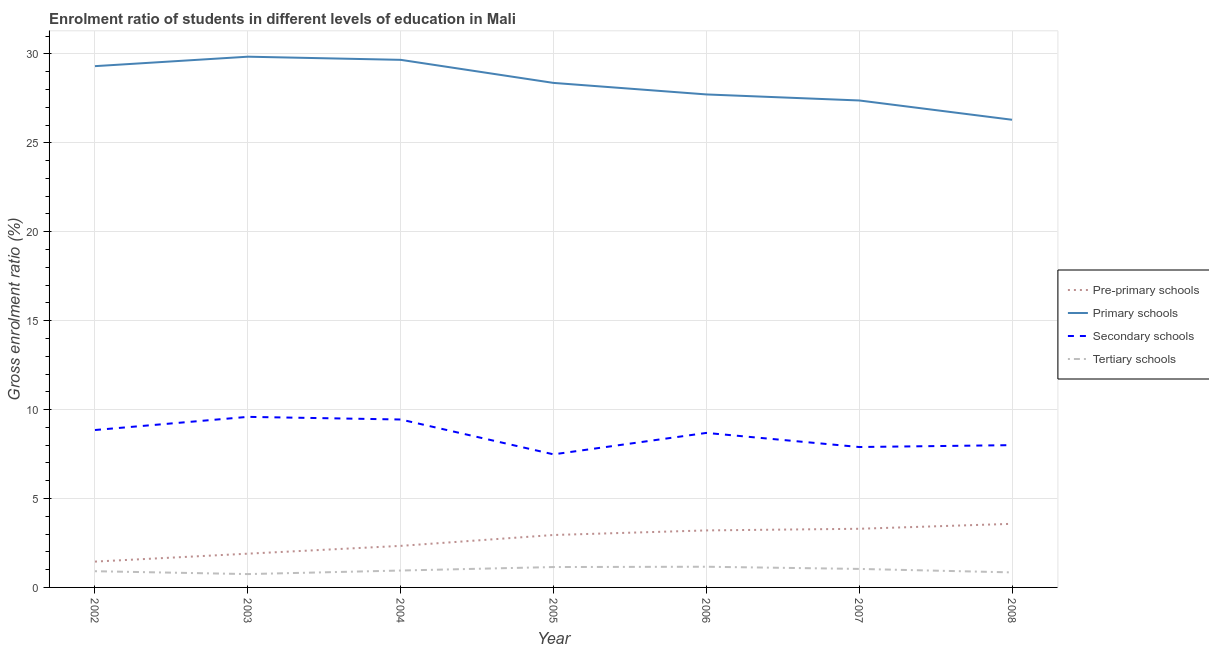How many different coloured lines are there?
Your answer should be compact. 4. What is the gross enrolment ratio in tertiary schools in 2005?
Your response must be concise. 1.15. Across all years, what is the maximum gross enrolment ratio in primary schools?
Keep it short and to the point. 29.84. Across all years, what is the minimum gross enrolment ratio in pre-primary schools?
Your answer should be compact. 1.45. In which year was the gross enrolment ratio in secondary schools maximum?
Provide a succinct answer. 2003. In which year was the gross enrolment ratio in primary schools minimum?
Ensure brevity in your answer.  2008. What is the total gross enrolment ratio in tertiary schools in the graph?
Ensure brevity in your answer.  6.81. What is the difference between the gross enrolment ratio in primary schools in 2005 and that in 2008?
Keep it short and to the point. 2.07. What is the difference between the gross enrolment ratio in primary schools in 2004 and the gross enrolment ratio in secondary schools in 2007?
Ensure brevity in your answer.  21.77. What is the average gross enrolment ratio in primary schools per year?
Make the answer very short. 28.37. In the year 2005, what is the difference between the gross enrolment ratio in primary schools and gross enrolment ratio in tertiary schools?
Give a very brief answer. 27.22. In how many years, is the gross enrolment ratio in secondary schools greater than 3 %?
Offer a terse response. 7. What is the ratio of the gross enrolment ratio in secondary schools in 2006 to that in 2007?
Your answer should be very brief. 1.1. Is the gross enrolment ratio in tertiary schools in 2002 less than that in 2005?
Ensure brevity in your answer.  Yes. What is the difference between the highest and the second highest gross enrolment ratio in tertiary schools?
Your answer should be very brief. 0.02. What is the difference between the highest and the lowest gross enrolment ratio in primary schools?
Give a very brief answer. 3.55. Does the gross enrolment ratio in secondary schools monotonically increase over the years?
Keep it short and to the point. No. Is the gross enrolment ratio in pre-primary schools strictly less than the gross enrolment ratio in tertiary schools over the years?
Provide a short and direct response. No. How many lines are there?
Keep it short and to the point. 4. Are the values on the major ticks of Y-axis written in scientific E-notation?
Provide a short and direct response. No. Does the graph contain any zero values?
Ensure brevity in your answer.  No. Does the graph contain grids?
Offer a terse response. Yes. How are the legend labels stacked?
Offer a terse response. Vertical. What is the title of the graph?
Make the answer very short. Enrolment ratio of students in different levels of education in Mali. What is the label or title of the X-axis?
Offer a terse response. Year. What is the Gross enrolment ratio (%) in Pre-primary schools in 2002?
Your answer should be compact. 1.45. What is the Gross enrolment ratio (%) in Primary schools in 2002?
Make the answer very short. 29.31. What is the Gross enrolment ratio (%) in Secondary schools in 2002?
Ensure brevity in your answer.  8.85. What is the Gross enrolment ratio (%) of Tertiary schools in 2002?
Your answer should be compact. 0.91. What is the Gross enrolment ratio (%) in Pre-primary schools in 2003?
Make the answer very short. 1.9. What is the Gross enrolment ratio (%) of Primary schools in 2003?
Your answer should be compact. 29.84. What is the Gross enrolment ratio (%) of Secondary schools in 2003?
Give a very brief answer. 9.59. What is the Gross enrolment ratio (%) of Tertiary schools in 2003?
Give a very brief answer. 0.75. What is the Gross enrolment ratio (%) in Pre-primary schools in 2004?
Your response must be concise. 2.34. What is the Gross enrolment ratio (%) of Primary schools in 2004?
Your response must be concise. 29.67. What is the Gross enrolment ratio (%) in Secondary schools in 2004?
Ensure brevity in your answer.  9.44. What is the Gross enrolment ratio (%) of Tertiary schools in 2004?
Make the answer very short. 0.95. What is the Gross enrolment ratio (%) in Pre-primary schools in 2005?
Your response must be concise. 2.95. What is the Gross enrolment ratio (%) in Primary schools in 2005?
Make the answer very short. 28.37. What is the Gross enrolment ratio (%) of Secondary schools in 2005?
Provide a short and direct response. 7.48. What is the Gross enrolment ratio (%) of Tertiary schools in 2005?
Your response must be concise. 1.15. What is the Gross enrolment ratio (%) of Pre-primary schools in 2006?
Make the answer very short. 3.21. What is the Gross enrolment ratio (%) of Primary schools in 2006?
Provide a succinct answer. 27.72. What is the Gross enrolment ratio (%) in Secondary schools in 2006?
Your answer should be compact. 8.69. What is the Gross enrolment ratio (%) of Tertiary schools in 2006?
Provide a short and direct response. 1.16. What is the Gross enrolment ratio (%) of Pre-primary schools in 2007?
Offer a very short reply. 3.3. What is the Gross enrolment ratio (%) in Primary schools in 2007?
Your answer should be very brief. 27.38. What is the Gross enrolment ratio (%) in Secondary schools in 2007?
Keep it short and to the point. 7.9. What is the Gross enrolment ratio (%) of Tertiary schools in 2007?
Offer a terse response. 1.04. What is the Gross enrolment ratio (%) of Pre-primary schools in 2008?
Give a very brief answer. 3.58. What is the Gross enrolment ratio (%) of Primary schools in 2008?
Offer a very short reply. 26.3. What is the Gross enrolment ratio (%) of Secondary schools in 2008?
Provide a short and direct response. 8. What is the Gross enrolment ratio (%) in Tertiary schools in 2008?
Keep it short and to the point. 0.85. Across all years, what is the maximum Gross enrolment ratio (%) of Pre-primary schools?
Your response must be concise. 3.58. Across all years, what is the maximum Gross enrolment ratio (%) of Primary schools?
Offer a very short reply. 29.84. Across all years, what is the maximum Gross enrolment ratio (%) in Secondary schools?
Your answer should be compact. 9.59. Across all years, what is the maximum Gross enrolment ratio (%) of Tertiary schools?
Your response must be concise. 1.16. Across all years, what is the minimum Gross enrolment ratio (%) in Pre-primary schools?
Your answer should be very brief. 1.45. Across all years, what is the minimum Gross enrolment ratio (%) of Primary schools?
Offer a very short reply. 26.3. Across all years, what is the minimum Gross enrolment ratio (%) in Secondary schools?
Provide a succinct answer. 7.48. Across all years, what is the minimum Gross enrolment ratio (%) of Tertiary schools?
Your answer should be very brief. 0.75. What is the total Gross enrolment ratio (%) of Pre-primary schools in the graph?
Provide a succinct answer. 18.72. What is the total Gross enrolment ratio (%) of Primary schools in the graph?
Your answer should be compact. 198.6. What is the total Gross enrolment ratio (%) in Secondary schools in the graph?
Offer a terse response. 59.95. What is the total Gross enrolment ratio (%) of Tertiary schools in the graph?
Ensure brevity in your answer.  6.81. What is the difference between the Gross enrolment ratio (%) in Pre-primary schools in 2002 and that in 2003?
Give a very brief answer. -0.45. What is the difference between the Gross enrolment ratio (%) in Primary schools in 2002 and that in 2003?
Ensure brevity in your answer.  -0.53. What is the difference between the Gross enrolment ratio (%) in Secondary schools in 2002 and that in 2003?
Give a very brief answer. -0.74. What is the difference between the Gross enrolment ratio (%) of Tertiary schools in 2002 and that in 2003?
Your answer should be very brief. 0.16. What is the difference between the Gross enrolment ratio (%) in Pre-primary schools in 2002 and that in 2004?
Your answer should be very brief. -0.88. What is the difference between the Gross enrolment ratio (%) of Primary schools in 2002 and that in 2004?
Your response must be concise. -0.35. What is the difference between the Gross enrolment ratio (%) of Secondary schools in 2002 and that in 2004?
Keep it short and to the point. -0.59. What is the difference between the Gross enrolment ratio (%) in Tertiary schools in 2002 and that in 2004?
Provide a short and direct response. -0.04. What is the difference between the Gross enrolment ratio (%) in Pre-primary schools in 2002 and that in 2005?
Offer a terse response. -1.5. What is the difference between the Gross enrolment ratio (%) in Primary schools in 2002 and that in 2005?
Your response must be concise. 0.94. What is the difference between the Gross enrolment ratio (%) in Secondary schools in 2002 and that in 2005?
Make the answer very short. 1.37. What is the difference between the Gross enrolment ratio (%) of Tertiary schools in 2002 and that in 2005?
Offer a very short reply. -0.23. What is the difference between the Gross enrolment ratio (%) in Pre-primary schools in 2002 and that in 2006?
Keep it short and to the point. -1.75. What is the difference between the Gross enrolment ratio (%) of Primary schools in 2002 and that in 2006?
Give a very brief answer. 1.59. What is the difference between the Gross enrolment ratio (%) of Secondary schools in 2002 and that in 2006?
Make the answer very short. 0.16. What is the difference between the Gross enrolment ratio (%) of Tertiary schools in 2002 and that in 2006?
Make the answer very short. -0.25. What is the difference between the Gross enrolment ratio (%) of Pre-primary schools in 2002 and that in 2007?
Provide a short and direct response. -1.85. What is the difference between the Gross enrolment ratio (%) in Primary schools in 2002 and that in 2007?
Ensure brevity in your answer.  1.93. What is the difference between the Gross enrolment ratio (%) in Secondary schools in 2002 and that in 2007?
Provide a short and direct response. 0.96. What is the difference between the Gross enrolment ratio (%) in Tertiary schools in 2002 and that in 2007?
Provide a succinct answer. -0.13. What is the difference between the Gross enrolment ratio (%) of Pre-primary schools in 2002 and that in 2008?
Keep it short and to the point. -2.12. What is the difference between the Gross enrolment ratio (%) of Primary schools in 2002 and that in 2008?
Provide a short and direct response. 3.01. What is the difference between the Gross enrolment ratio (%) of Secondary schools in 2002 and that in 2008?
Your response must be concise. 0.85. What is the difference between the Gross enrolment ratio (%) in Tertiary schools in 2002 and that in 2008?
Your answer should be very brief. 0.07. What is the difference between the Gross enrolment ratio (%) of Pre-primary schools in 2003 and that in 2004?
Offer a terse response. -0.44. What is the difference between the Gross enrolment ratio (%) of Primary schools in 2003 and that in 2004?
Offer a very short reply. 0.18. What is the difference between the Gross enrolment ratio (%) of Secondary schools in 2003 and that in 2004?
Your answer should be very brief. 0.15. What is the difference between the Gross enrolment ratio (%) in Tertiary schools in 2003 and that in 2004?
Ensure brevity in your answer.  -0.2. What is the difference between the Gross enrolment ratio (%) in Pre-primary schools in 2003 and that in 2005?
Your response must be concise. -1.05. What is the difference between the Gross enrolment ratio (%) of Primary schools in 2003 and that in 2005?
Offer a terse response. 1.47. What is the difference between the Gross enrolment ratio (%) in Secondary schools in 2003 and that in 2005?
Give a very brief answer. 2.11. What is the difference between the Gross enrolment ratio (%) of Tertiary schools in 2003 and that in 2005?
Provide a succinct answer. -0.4. What is the difference between the Gross enrolment ratio (%) of Pre-primary schools in 2003 and that in 2006?
Provide a short and direct response. -1.31. What is the difference between the Gross enrolment ratio (%) in Primary schools in 2003 and that in 2006?
Provide a succinct answer. 2.12. What is the difference between the Gross enrolment ratio (%) in Secondary schools in 2003 and that in 2006?
Keep it short and to the point. 0.9. What is the difference between the Gross enrolment ratio (%) of Tertiary schools in 2003 and that in 2006?
Provide a short and direct response. -0.41. What is the difference between the Gross enrolment ratio (%) in Pre-primary schools in 2003 and that in 2007?
Offer a terse response. -1.4. What is the difference between the Gross enrolment ratio (%) in Primary schools in 2003 and that in 2007?
Your answer should be very brief. 2.46. What is the difference between the Gross enrolment ratio (%) in Secondary schools in 2003 and that in 2007?
Your answer should be very brief. 1.7. What is the difference between the Gross enrolment ratio (%) in Tertiary schools in 2003 and that in 2007?
Give a very brief answer. -0.29. What is the difference between the Gross enrolment ratio (%) in Pre-primary schools in 2003 and that in 2008?
Your answer should be compact. -1.68. What is the difference between the Gross enrolment ratio (%) of Primary schools in 2003 and that in 2008?
Give a very brief answer. 3.55. What is the difference between the Gross enrolment ratio (%) in Secondary schools in 2003 and that in 2008?
Your response must be concise. 1.59. What is the difference between the Gross enrolment ratio (%) of Tertiary schools in 2003 and that in 2008?
Keep it short and to the point. -0.1. What is the difference between the Gross enrolment ratio (%) of Pre-primary schools in 2004 and that in 2005?
Keep it short and to the point. -0.61. What is the difference between the Gross enrolment ratio (%) in Primary schools in 2004 and that in 2005?
Keep it short and to the point. 1.3. What is the difference between the Gross enrolment ratio (%) in Secondary schools in 2004 and that in 2005?
Give a very brief answer. 1.96. What is the difference between the Gross enrolment ratio (%) in Tertiary schools in 2004 and that in 2005?
Ensure brevity in your answer.  -0.2. What is the difference between the Gross enrolment ratio (%) of Pre-primary schools in 2004 and that in 2006?
Provide a short and direct response. -0.87. What is the difference between the Gross enrolment ratio (%) in Primary schools in 2004 and that in 2006?
Provide a short and direct response. 1.95. What is the difference between the Gross enrolment ratio (%) of Secondary schools in 2004 and that in 2006?
Give a very brief answer. 0.75. What is the difference between the Gross enrolment ratio (%) of Tertiary schools in 2004 and that in 2006?
Offer a terse response. -0.21. What is the difference between the Gross enrolment ratio (%) of Pre-primary schools in 2004 and that in 2007?
Provide a succinct answer. -0.96. What is the difference between the Gross enrolment ratio (%) in Primary schools in 2004 and that in 2007?
Your response must be concise. 2.28. What is the difference between the Gross enrolment ratio (%) in Secondary schools in 2004 and that in 2007?
Give a very brief answer. 1.55. What is the difference between the Gross enrolment ratio (%) in Tertiary schools in 2004 and that in 2007?
Offer a terse response. -0.09. What is the difference between the Gross enrolment ratio (%) of Pre-primary schools in 2004 and that in 2008?
Offer a very short reply. -1.24. What is the difference between the Gross enrolment ratio (%) of Primary schools in 2004 and that in 2008?
Ensure brevity in your answer.  3.37. What is the difference between the Gross enrolment ratio (%) in Secondary schools in 2004 and that in 2008?
Offer a very short reply. 1.44. What is the difference between the Gross enrolment ratio (%) of Tertiary schools in 2004 and that in 2008?
Offer a terse response. 0.1. What is the difference between the Gross enrolment ratio (%) of Pre-primary schools in 2005 and that in 2006?
Ensure brevity in your answer.  -0.26. What is the difference between the Gross enrolment ratio (%) of Primary schools in 2005 and that in 2006?
Your answer should be very brief. 0.65. What is the difference between the Gross enrolment ratio (%) in Secondary schools in 2005 and that in 2006?
Ensure brevity in your answer.  -1.21. What is the difference between the Gross enrolment ratio (%) in Tertiary schools in 2005 and that in 2006?
Your answer should be compact. -0.02. What is the difference between the Gross enrolment ratio (%) of Pre-primary schools in 2005 and that in 2007?
Offer a terse response. -0.35. What is the difference between the Gross enrolment ratio (%) in Primary schools in 2005 and that in 2007?
Your response must be concise. 0.99. What is the difference between the Gross enrolment ratio (%) of Secondary schools in 2005 and that in 2007?
Offer a terse response. -0.41. What is the difference between the Gross enrolment ratio (%) in Tertiary schools in 2005 and that in 2007?
Give a very brief answer. 0.11. What is the difference between the Gross enrolment ratio (%) of Pre-primary schools in 2005 and that in 2008?
Your answer should be compact. -0.63. What is the difference between the Gross enrolment ratio (%) in Primary schools in 2005 and that in 2008?
Ensure brevity in your answer.  2.07. What is the difference between the Gross enrolment ratio (%) in Secondary schools in 2005 and that in 2008?
Keep it short and to the point. -0.52. What is the difference between the Gross enrolment ratio (%) of Tertiary schools in 2005 and that in 2008?
Ensure brevity in your answer.  0.3. What is the difference between the Gross enrolment ratio (%) in Pre-primary schools in 2006 and that in 2007?
Offer a very short reply. -0.09. What is the difference between the Gross enrolment ratio (%) in Primary schools in 2006 and that in 2007?
Give a very brief answer. 0.34. What is the difference between the Gross enrolment ratio (%) of Secondary schools in 2006 and that in 2007?
Provide a short and direct response. 0.79. What is the difference between the Gross enrolment ratio (%) of Tertiary schools in 2006 and that in 2007?
Ensure brevity in your answer.  0.12. What is the difference between the Gross enrolment ratio (%) in Pre-primary schools in 2006 and that in 2008?
Offer a terse response. -0.37. What is the difference between the Gross enrolment ratio (%) in Primary schools in 2006 and that in 2008?
Your answer should be very brief. 1.42. What is the difference between the Gross enrolment ratio (%) of Secondary schools in 2006 and that in 2008?
Give a very brief answer. 0.69. What is the difference between the Gross enrolment ratio (%) of Tertiary schools in 2006 and that in 2008?
Offer a terse response. 0.32. What is the difference between the Gross enrolment ratio (%) in Pre-primary schools in 2007 and that in 2008?
Your answer should be very brief. -0.28. What is the difference between the Gross enrolment ratio (%) in Primary schools in 2007 and that in 2008?
Your response must be concise. 1.08. What is the difference between the Gross enrolment ratio (%) of Secondary schools in 2007 and that in 2008?
Your response must be concise. -0.11. What is the difference between the Gross enrolment ratio (%) of Tertiary schools in 2007 and that in 2008?
Your answer should be compact. 0.2. What is the difference between the Gross enrolment ratio (%) in Pre-primary schools in 2002 and the Gross enrolment ratio (%) in Primary schools in 2003?
Make the answer very short. -28.39. What is the difference between the Gross enrolment ratio (%) in Pre-primary schools in 2002 and the Gross enrolment ratio (%) in Secondary schools in 2003?
Keep it short and to the point. -8.14. What is the difference between the Gross enrolment ratio (%) of Pre-primary schools in 2002 and the Gross enrolment ratio (%) of Tertiary schools in 2003?
Your answer should be very brief. 0.7. What is the difference between the Gross enrolment ratio (%) in Primary schools in 2002 and the Gross enrolment ratio (%) in Secondary schools in 2003?
Your answer should be compact. 19.72. What is the difference between the Gross enrolment ratio (%) in Primary schools in 2002 and the Gross enrolment ratio (%) in Tertiary schools in 2003?
Your answer should be very brief. 28.56. What is the difference between the Gross enrolment ratio (%) in Secondary schools in 2002 and the Gross enrolment ratio (%) in Tertiary schools in 2003?
Ensure brevity in your answer.  8.1. What is the difference between the Gross enrolment ratio (%) of Pre-primary schools in 2002 and the Gross enrolment ratio (%) of Primary schools in 2004?
Make the answer very short. -28.21. What is the difference between the Gross enrolment ratio (%) in Pre-primary schools in 2002 and the Gross enrolment ratio (%) in Secondary schools in 2004?
Offer a terse response. -7.99. What is the difference between the Gross enrolment ratio (%) in Pre-primary schools in 2002 and the Gross enrolment ratio (%) in Tertiary schools in 2004?
Your answer should be compact. 0.5. What is the difference between the Gross enrolment ratio (%) in Primary schools in 2002 and the Gross enrolment ratio (%) in Secondary schools in 2004?
Keep it short and to the point. 19.87. What is the difference between the Gross enrolment ratio (%) in Primary schools in 2002 and the Gross enrolment ratio (%) in Tertiary schools in 2004?
Provide a short and direct response. 28.36. What is the difference between the Gross enrolment ratio (%) of Secondary schools in 2002 and the Gross enrolment ratio (%) of Tertiary schools in 2004?
Offer a terse response. 7.9. What is the difference between the Gross enrolment ratio (%) of Pre-primary schools in 2002 and the Gross enrolment ratio (%) of Primary schools in 2005?
Make the answer very short. -26.92. What is the difference between the Gross enrolment ratio (%) of Pre-primary schools in 2002 and the Gross enrolment ratio (%) of Secondary schools in 2005?
Keep it short and to the point. -6.03. What is the difference between the Gross enrolment ratio (%) of Pre-primary schools in 2002 and the Gross enrolment ratio (%) of Tertiary schools in 2005?
Offer a terse response. 0.31. What is the difference between the Gross enrolment ratio (%) of Primary schools in 2002 and the Gross enrolment ratio (%) of Secondary schools in 2005?
Keep it short and to the point. 21.83. What is the difference between the Gross enrolment ratio (%) of Primary schools in 2002 and the Gross enrolment ratio (%) of Tertiary schools in 2005?
Provide a short and direct response. 28.17. What is the difference between the Gross enrolment ratio (%) in Secondary schools in 2002 and the Gross enrolment ratio (%) in Tertiary schools in 2005?
Ensure brevity in your answer.  7.71. What is the difference between the Gross enrolment ratio (%) of Pre-primary schools in 2002 and the Gross enrolment ratio (%) of Primary schools in 2006?
Ensure brevity in your answer.  -26.27. What is the difference between the Gross enrolment ratio (%) of Pre-primary schools in 2002 and the Gross enrolment ratio (%) of Secondary schools in 2006?
Give a very brief answer. -7.24. What is the difference between the Gross enrolment ratio (%) of Pre-primary schools in 2002 and the Gross enrolment ratio (%) of Tertiary schools in 2006?
Offer a very short reply. 0.29. What is the difference between the Gross enrolment ratio (%) of Primary schools in 2002 and the Gross enrolment ratio (%) of Secondary schools in 2006?
Provide a short and direct response. 20.62. What is the difference between the Gross enrolment ratio (%) in Primary schools in 2002 and the Gross enrolment ratio (%) in Tertiary schools in 2006?
Provide a short and direct response. 28.15. What is the difference between the Gross enrolment ratio (%) in Secondary schools in 2002 and the Gross enrolment ratio (%) in Tertiary schools in 2006?
Make the answer very short. 7.69. What is the difference between the Gross enrolment ratio (%) in Pre-primary schools in 2002 and the Gross enrolment ratio (%) in Primary schools in 2007?
Your response must be concise. -25.93. What is the difference between the Gross enrolment ratio (%) in Pre-primary schools in 2002 and the Gross enrolment ratio (%) in Secondary schools in 2007?
Ensure brevity in your answer.  -6.44. What is the difference between the Gross enrolment ratio (%) of Pre-primary schools in 2002 and the Gross enrolment ratio (%) of Tertiary schools in 2007?
Keep it short and to the point. 0.41. What is the difference between the Gross enrolment ratio (%) of Primary schools in 2002 and the Gross enrolment ratio (%) of Secondary schools in 2007?
Make the answer very short. 21.42. What is the difference between the Gross enrolment ratio (%) of Primary schools in 2002 and the Gross enrolment ratio (%) of Tertiary schools in 2007?
Your response must be concise. 28.27. What is the difference between the Gross enrolment ratio (%) in Secondary schools in 2002 and the Gross enrolment ratio (%) in Tertiary schools in 2007?
Make the answer very short. 7.81. What is the difference between the Gross enrolment ratio (%) in Pre-primary schools in 2002 and the Gross enrolment ratio (%) in Primary schools in 2008?
Give a very brief answer. -24.85. What is the difference between the Gross enrolment ratio (%) in Pre-primary schools in 2002 and the Gross enrolment ratio (%) in Secondary schools in 2008?
Ensure brevity in your answer.  -6.55. What is the difference between the Gross enrolment ratio (%) in Pre-primary schools in 2002 and the Gross enrolment ratio (%) in Tertiary schools in 2008?
Provide a short and direct response. 0.61. What is the difference between the Gross enrolment ratio (%) in Primary schools in 2002 and the Gross enrolment ratio (%) in Secondary schools in 2008?
Your answer should be very brief. 21.31. What is the difference between the Gross enrolment ratio (%) of Primary schools in 2002 and the Gross enrolment ratio (%) of Tertiary schools in 2008?
Offer a terse response. 28.47. What is the difference between the Gross enrolment ratio (%) in Secondary schools in 2002 and the Gross enrolment ratio (%) in Tertiary schools in 2008?
Keep it short and to the point. 8.01. What is the difference between the Gross enrolment ratio (%) of Pre-primary schools in 2003 and the Gross enrolment ratio (%) of Primary schools in 2004?
Offer a very short reply. -27.77. What is the difference between the Gross enrolment ratio (%) of Pre-primary schools in 2003 and the Gross enrolment ratio (%) of Secondary schools in 2004?
Provide a succinct answer. -7.54. What is the difference between the Gross enrolment ratio (%) of Pre-primary schools in 2003 and the Gross enrolment ratio (%) of Tertiary schools in 2004?
Offer a very short reply. 0.95. What is the difference between the Gross enrolment ratio (%) in Primary schools in 2003 and the Gross enrolment ratio (%) in Secondary schools in 2004?
Give a very brief answer. 20.4. What is the difference between the Gross enrolment ratio (%) in Primary schools in 2003 and the Gross enrolment ratio (%) in Tertiary schools in 2004?
Ensure brevity in your answer.  28.89. What is the difference between the Gross enrolment ratio (%) in Secondary schools in 2003 and the Gross enrolment ratio (%) in Tertiary schools in 2004?
Keep it short and to the point. 8.64. What is the difference between the Gross enrolment ratio (%) in Pre-primary schools in 2003 and the Gross enrolment ratio (%) in Primary schools in 2005?
Offer a terse response. -26.47. What is the difference between the Gross enrolment ratio (%) in Pre-primary schools in 2003 and the Gross enrolment ratio (%) in Secondary schools in 2005?
Your response must be concise. -5.58. What is the difference between the Gross enrolment ratio (%) in Pre-primary schools in 2003 and the Gross enrolment ratio (%) in Tertiary schools in 2005?
Give a very brief answer. 0.75. What is the difference between the Gross enrolment ratio (%) of Primary schools in 2003 and the Gross enrolment ratio (%) of Secondary schools in 2005?
Provide a succinct answer. 22.36. What is the difference between the Gross enrolment ratio (%) in Primary schools in 2003 and the Gross enrolment ratio (%) in Tertiary schools in 2005?
Offer a very short reply. 28.7. What is the difference between the Gross enrolment ratio (%) in Secondary schools in 2003 and the Gross enrolment ratio (%) in Tertiary schools in 2005?
Give a very brief answer. 8.44. What is the difference between the Gross enrolment ratio (%) in Pre-primary schools in 2003 and the Gross enrolment ratio (%) in Primary schools in 2006?
Provide a succinct answer. -25.82. What is the difference between the Gross enrolment ratio (%) of Pre-primary schools in 2003 and the Gross enrolment ratio (%) of Secondary schools in 2006?
Provide a short and direct response. -6.79. What is the difference between the Gross enrolment ratio (%) of Pre-primary schools in 2003 and the Gross enrolment ratio (%) of Tertiary schools in 2006?
Your answer should be compact. 0.73. What is the difference between the Gross enrolment ratio (%) in Primary schools in 2003 and the Gross enrolment ratio (%) in Secondary schools in 2006?
Your answer should be very brief. 21.16. What is the difference between the Gross enrolment ratio (%) of Primary schools in 2003 and the Gross enrolment ratio (%) of Tertiary schools in 2006?
Keep it short and to the point. 28.68. What is the difference between the Gross enrolment ratio (%) of Secondary schools in 2003 and the Gross enrolment ratio (%) of Tertiary schools in 2006?
Your answer should be very brief. 8.43. What is the difference between the Gross enrolment ratio (%) of Pre-primary schools in 2003 and the Gross enrolment ratio (%) of Primary schools in 2007?
Keep it short and to the point. -25.48. What is the difference between the Gross enrolment ratio (%) of Pre-primary schools in 2003 and the Gross enrolment ratio (%) of Secondary schools in 2007?
Your answer should be very brief. -6. What is the difference between the Gross enrolment ratio (%) in Pre-primary schools in 2003 and the Gross enrolment ratio (%) in Tertiary schools in 2007?
Offer a terse response. 0.86. What is the difference between the Gross enrolment ratio (%) of Primary schools in 2003 and the Gross enrolment ratio (%) of Secondary schools in 2007?
Offer a terse response. 21.95. What is the difference between the Gross enrolment ratio (%) in Primary schools in 2003 and the Gross enrolment ratio (%) in Tertiary schools in 2007?
Provide a succinct answer. 28.8. What is the difference between the Gross enrolment ratio (%) of Secondary schools in 2003 and the Gross enrolment ratio (%) of Tertiary schools in 2007?
Provide a short and direct response. 8.55. What is the difference between the Gross enrolment ratio (%) in Pre-primary schools in 2003 and the Gross enrolment ratio (%) in Primary schools in 2008?
Your response must be concise. -24.4. What is the difference between the Gross enrolment ratio (%) of Pre-primary schools in 2003 and the Gross enrolment ratio (%) of Secondary schools in 2008?
Give a very brief answer. -6.1. What is the difference between the Gross enrolment ratio (%) in Pre-primary schools in 2003 and the Gross enrolment ratio (%) in Tertiary schools in 2008?
Offer a very short reply. 1.05. What is the difference between the Gross enrolment ratio (%) of Primary schools in 2003 and the Gross enrolment ratio (%) of Secondary schools in 2008?
Keep it short and to the point. 21.84. What is the difference between the Gross enrolment ratio (%) in Primary schools in 2003 and the Gross enrolment ratio (%) in Tertiary schools in 2008?
Keep it short and to the point. 29. What is the difference between the Gross enrolment ratio (%) of Secondary schools in 2003 and the Gross enrolment ratio (%) of Tertiary schools in 2008?
Provide a short and direct response. 8.75. What is the difference between the Gross enrolment ratio (%) of Pre-primary schools in 2004 and the Gross enrolment ratio (%) of Primary schools in 2005?
Keep it short and to the point. -26.03. What is the difference between the Gross enrolment ratio (%) of Pre-primary schools in 2004 and the Gross enrolment ratio (%) of Secondary schools in 2005?
Give a very brief answer. -5.15. What is the difference between the Gross enrolment ratio (%) in Pre-primary schools in 2004 and the Gross enrolment ratio (%) in Tertiary schools in 2005?
Offer a very short reply. 1.19. What is the difference between the Gross enrolment ratio (%) of Primary schools in 2004 and the Gross enrolment ratio (%) of Secondary schools in 2005?
Your answer should be compact. 22.18. What is the difference between the Gross enrolment ratio (%) of Primary schools in 2004 and the Gross enrolment ratio (%) of Tertiary schools in 2005?
Your response must be concise. 28.52. What is the difference between the Gross enrolment ratio (%) of Secondary schools in 2004 and the Gross enrolment ratio (%) of Tertiary schools in 2005?
Keep it short and to the point. 8.3. What is the difference between the Gross enrolment ratio (%) of Pre-primary schools in 2004 and the Gross enrolment ratio (%) of Primary schools in 2006?
Your response must be concise. -25.39. What is the difference between the Gross enrolment ratio (%) in Pre-primary schools in 2004 and the Gross enrolment ratio (%) in Secondary schools in 2006?
Ensure brevity in your answer.  -6.35. What is the difference between the Gross enrolment ratio (%) in Pre-primary schools in 2004 and the Gross enrolment ratio (%) in Tertiary schools in 2006?
Ensure brevity in your answer.  1.17. What is the difference between the Gross enrolment ratio (%) in Primary schools in 2004 and the Gross enrolment ratio (%) in Secondary schools in 2006?
Your answer should be compact. 20.98. What is the difference between the Gross enrolment ratio (%) of Primary schools in 2004 and the Gross enrolment ratio (%) of Tertiary schools in 2006?
Give a very brief answer. 28.5. What is the difference between the Gross enrolment ratio (%) of Secondary schools in 2004 and the Gross enrolment ratio (%) of Tertiary schools in 2006?
Give a very brief answer. 8.28. What is the difference between the Gross enrolment ratio (%) in Pre-primary schools in 2004 and the Gross enrolment ratio (%) in Primary schools in 2007?
Keep it short and to the point. -25.05. What is the difference between the Gross enrolment ratio (%) of Pre-primary schools in 2004 and the Gross enrolment ratio (%) of Secondary schools in 2007?
Ensure brevity in your answer.  -5.56. What is the difference between the Gross enrolment ratio (%) in Pre-primary schools in 2004 and the Gross enrolment ratio (%) in Tertiary schools in 2007?
Your response must be concise. 1.3. What is the difference between the Gross enrolment ratio (%) of Primary schools in 2004 and the Gross enrolment ratio (%) of Secondary schools in 2007?
Provide a succinct answer. 21.77. What is the difference between the Gross enrolment ratio (%) of Primary schools in 2004 and the Gross enrolment ratio (%) of Tertiary schools in 2007?
Make the answer very short. 28.63. What is the difference between the Gross enrolment ratio (%) in Secondary schools in 2004 and the Gross enrolment ratio (%) in Tertiary schools in 2007?
Keep it short and to the point. 8.4. What is the difference between the Gross enrolment ratio (%) of Pre-primary schools in 2004 and the Gross enrolment ratio (%) of Primary schools in 2008?
Your answer should be very brief. -23.96. What is the difference between the Gross enrolment ratio (%) in Pre-primary schools in 2004 and the Gross enrolment ratio (%) in Secondary schools in 2008?
Provide a succinct answer. -5.66. What is the difference between the Gross enrolment ratio (%) of Pre-primary schools in 2004 and the Gross enrolment ratio (%) of Tertiary schools in 2008?
Offer a terse response. 1.49. What is the difference between the Gross enrolment ratio (%) in Primary schools in 2004 and the Gross enrolment ratio (%) in Secondary schools in 2008?
Offer a terse response. 21.67. What is the difference between the Gross enrolment ratio (%) in Primary schools in 2004 and the Gross enrolment ratio (%) in Tertiary schools in 2008?
Your response must be concise. 28.82. What is the difference between the Gross enrolment ratio (%) of Secondary schools in 2004 and the Gross enrolment ratio (%) of Tertiary schools in 2008?
Offer a terse response. 8.6. What is the difference between the Gross enrolment ratio (%) in Pre-primary schools in 2005 and the Gross enrolment ratio (%) in Primary schools in 2006?
Your answer should be very brief. -24.77. What is the difference between the Gross enrolment ratio (%) in Pre-primary schools in 2005 and the Gross enrolment ratio (%) in Secondary schools in 2006?
Your answer should be compact. -5.74. What is the difference between the Gross enrolment ratio (%) of Pre-primary schools in 2005 and the Gross enrolment ratio (%) of Tertiary schools in 2006?
Ensure brevity in your answer.  1.78. What is the difference between the Gross enrolment ratio (%) of Primary schools in 2005 and the Gross enrolment ratio (%) of Secondary schools in 2006?
Your response must be concise. 19.68. What is the difference between the Gross enrolment ratio (%) of Primary schools in 2005 and the Gross enrolment ratio (%) of Tertiary schools in 2006?
Your answer should be compact. 27.21. What is the difference between the Gross enrolment ratio (%) in Secondary schools in 2005 and the Gross enrolment ratio (%) in Tertiary schools in 2006?
Provide a succinct answer. 6.32. What is the difference between the Gross enrolment ratio (%) in Pre-primary schools in 2005 and the Gross enrolment ratio (%) in Primary schools in 2007?
Your response must be concise. -24.43. What is the difference between the Gross enrolment ratio (%) of Pre-primary schools in 2005 and the Gross enrolment ratio (%) of Secondary schools in 2007?
Ensure brevity in your answer.  -4.95. What is the difference between the Gross enrolment ratio (%) of Pre-primary schools in 2005 and the Gross enrolment ratio (%) of Tertiary schools in 2007?
Provide a succinct answer. 1.91. What is the difference between the Gross enrolment ratio (%) in Primary schools in 2005 and the Gross enrolment ratio (%) in Secondary schools in 2007?
Your answer should be very brief. 20.47. What is the difference between the Gross enrolment ratio (%) in Primary schools in 2005 and the Gross enrolment ratio (%) in Tertiary schools in 2007?
Ensure brevity in your answer.  27.33. What is the difference between the Gross enrolment ratio (%) of Secondary schools in 2005 and the Gross enrolment ratio (%) of Tertiary schools in 2007?
Give a very brief answer. 6.44. What is the difference between the Gross enrolment ratio (%) in Pre-primary schools in 2005 and the Gross enrolment ratio (%) in Primary schools in 2008?
Your answer should be very brief. -23.35. What is the difference between the Gross enrolment ratio (%) of Pre-primary schools in 2005 and the Gross enrolment ratio (%) of Secondary schools in 2008?
Provide a short and direct response. -5.05. What is the difference between the Gross enrolment ratio (%) in Pre-primary schools in 2005 and the Gross enrolment ratio (%) in Tertiary schools in 2008?
Give a very brief answer. 2.1. What is the difference between the Gross enrolment ratio (%) in Primary schools in 2005 and the Gross enrolment ratio (%) in Secondary schools in 2008?
Your answer should be compact. 20.37. What is the difference between the Gross enrolment ratio (%) of Primary schools in 2005 and the Gross enrolment ratio (%) of Tertiary schools in 2008?
Your answer should be compact. 27.52. What is the difference between the Gross enrolment ratio (%) of Secondary schools in 2005 and the Gross enrolment ratio (%) of Tertiary schools in 2008?
Provide a succinct answer. 6.64. What is the difference between the Gross enrolment ratio (%) of Pre-primary schools in 2006 and the Gross enrolment ratio (%) of Primary schools in 2007?
Your answer should be compact. -24.18. What is the difference between the Gross enrolment ratio (%) of Pre-primary schools in 2006 and the Gross enrolment ratio (%) of Secondary schools in 2007?
Give a very brief answer. -4.69. What is the difference between the Gross enrolment ratio (%) in Pre-primary schools in 2006 and the Gross enrolment ratio (%) in Tertiary schools in 2007?
Provide a succinct answer. 2.17. What is the difference between the Gross enrolment ratio (%) of Primary schools in 2006 and the Gross enrolment ratio (%) of Secondary schools in 2007?
Offer a very short reply. 19.83. What is the difference between the Gross enrolment ratio (%) in Primary schools in 2006 and the Gross enrolment ratio (%) in Tertiary schools in 2007?
Keep it short and to the point. 26.68. What is the difference between the Gross enrolment ratio (%) in Secondary schools in 2006 and the Gross enrolment ratio (%) in Tertiary schools in 2007?
Provide a succinct answer. 7.65. What is the difference between the Gross enrolment ratio (%) in Pre-primary schools in 2006 and the Gross enrolment ratio (%) in Primary schools in 2008?
Your answer should be very brief. -23.09. What is the difference between the Gross enrolment ratio (%) in Pre-primary schools in 2006 and the Gross enrolment ratio (%) in Secondary schools in 2008?
Give a very brief answer. -4.8. What is the difference between the Gross enrolment ratio (%) of Pre-primary schools in 2006 and the Gross enrolment ratio (%) of Tertiary schools in 2008?
Provide a short and direct response. 2.36. What is the difference between the Gross enrolment ratio (%) of Primary schools in 2006 and the Gross enrolment ratio (%) of Secondary schools in 2008?
Give a very brief answer. 19.72. What is the difference between the Gross enrolment ratio (%) in Primary schools in 2006 and the Gross enrolment ratio (%) in Tertiary schools in 2008?
Give a very brief answer. 26.88. What is the difference between the Gross enrolment ratio (%) in Secondary schools in 2006 and the Gross enrolment ratio (%) in Tertiary schools in 2008?
Offer a very short reply. 7.84. What is the difference between the Gross enrolment ratio (%) in Pre-primary schools in 2007 and the Gross enrolment ratio (%) in Primary schools in 2008?
Your response must be concise. -23. What is the difference between the Gross enrolment ratio (%) in Pre-primary schools in 2007 and the Gross enrolment ratio (%) in Secondary schools in 2008?
Your answer should be very brief. -4.7. What is the difference between the Gross enrolment ratio (%) of Pre-primary schools in 2007 and the Gross enrolment ratio (%) of Tertiary schools in 2008?
Provide a short and direct response. 2.45. What is the difference between the Gross enrolment ratio (%) in Primary schools in 2007 and the Gross enrolment ratio (%) in Secondary schools in 2008?
Make the answer very short. 19.38. What is the difference between the Gross enrolment ratio (%) of Primary schools in 2007 and the Gross enrolment ratio (%) of Tertiary schools in 2008?
Your response must be concise. 26.54. What is the difference between the Gross enrolment ratio (%) of Secondary schools in 2007 and the Gross enrolment ratio (%) of Tertiary schools in 2008?
Your response must be concise. 7.05. What is the average Gross enrolment ratio (%) in Pre-primary schools per year?
Ensure brevity in your answer.  2.67. What is the average Gross enrolment ratio (%) of Primary schools per year?
Keep it short and to the point. 28.37. What is the average Gross enrolment ratio (%) in Secondary schools per year?
Your answer should be very brief. 8.56. What is the average Gross enrolment ratio (%) of Tertiary schools per year?
Make the answer very short. 0.97. In the year 2002, what is the difference between the Gross enrolment ratio (%) of Pre-primary schools and Gross enrolment ratio (%) of Primary schools?
Provide a succinct answer. -27.86. In the year 2002, what is the difference between the Gross enrolment ratio (%) of Pre-primary schools and Gross enrolment ratio (%) of Secondary schools?
Offer a very short reply. -7.4. In the year 2002, what is the difference between the Gross enrolment ratio (%) of Pre-primary schools and Gross enrolment ratio (%) of Tertiary schools?
Keep it short and to the point. 0.54. In the year 2002, what is the difference between the Gross enrolment ratio (%) in Primary schools and Gross enrolment ratio (%) in Secondary schools?
Give a very brief answer. 20.46. In the year 2002, what is the difference between the Gross enrolment ratio (%) in Primary schools and Gross enrolment ratio (%) in Tertiary schools?
Provide a short and direct response. 28.4. In the year 2002, what is the difference between the Gross enrolment ratio (%) in Secondary schools and Gross enrolment ratio (%) in Tertiary schools?
Provide a short and direct response. 7.94. In the year 2003, what is the difference between the Gross enrolment ratio (%) in Pre-primary schools and Gross enrolment ratio (%) in Primary schools?
Make the answer very short. -27.95. In the year 2003, what is the difference between the Gross enrolment ratio (%) of Pre-primary schools and Gross enrolment ratio (%) of Secondary schools?
Provide a succinct answer. -7.69. In the year 2003, what is the difference between the Gross enrolment ratio (%) of Pre-primary schools and Gross enrolment ratio (%) of Tertiary schools?
Give a very brief answer. 1.15. In the year 2003, what is the difference between the Gross enrolment ratio (%) in Primary schools and Gross enrolment ratio (%) in Secondary schools?
Give a very brief answer. 20.25. In the year 2003, what is the difference between the Gross enrolment ratio (%) of Primary schools and Gross enrolment ratio (%) of Tertiary schools?
Your answer should be very brief. 29.09. In the year 2003, what is the difference between the Gross enrolment ratio (%) of Secondary schools and Gross enrolment ratio (%) of Tertiary schools?
Your answer should be very brief. 8.84. In the year 2004, what is the difference between the Gross enrolment ratio (%) in Pre-primary schools and Gross enrolment ratio (%) in Primary schools?
Offer a very short reply. -27.33. In the year 2004, what is the difference between the Gross enrolment ratio (%) of Pre-primary schools and Gross enrolment ratio (%) of Secondary schools?
Provide a short and direct response. -7.11. In the year 2004, what is the difference between the Gross enrolment ratio (%) in Pre-primary schools and Gross enrolment ratio (%) in Tertiary schools?
Your answer should be very brief. 1.39. In the year 2004, what is the difference between the Gross enrolment ratio (%) of Primary schools and Gross enrolment ratio (%) of Secondary schools?
Provide a short and direct response. 20.22. In the year 2004, what is the difference between the Gross enrolment ratio (%) of Primary schools and Gross enrolment ratio (%) of Tertiary schools?
Provide a short and direct response. 28.72. In the year 2004, what is the difference between the Gross enrolment ratio (%) in Secondary schools and Gross enrolment ratio (%) in Tertiary schools?
Provide a succinct answer. 8.49. In the year 2005, what is the difference between the Gross enrolment ratio (%) in Pre-primary schools and Gross enrolment ratio (%) in Primary schools?
Your response must be concise. -25.42. In the year 2005, what is the difference between the Gross enrolment ratio (%) in Pre-primary schools and Gross enrolment ratio (%) in Secondary schools?
Your answer should be compact. -4.53. In the year 2005, what is the difference between the Gross enrolment ratio (%) in Pre-primary schools and Gross enrolment ratio (%) in Tertiary schools?
Provide a succinct answer. 1.8. In the year 2005, what is the difference between the Gross enrolment ratio (%) in Primary schools and Gross enrolment ratio (%) in Secondary schools?
Make the answer very short. 20.89. In the year 2005, what is the difference between the Gross enrolment ratio (%) of Primary schools and Gross enrolment ratio (%) of Tertiary schools?
Provide a short and direct response. 27.22. In the year 2005, what is the difference between the Gross enrolment ratio (%) in Secondary schools and Gross enrolment ratio (%) in Tertiary schools?
Offer a very short reply. 6.34. In the year 2006, what is the difference between the Gross enrolment ratio (%) of Pre-primary schools and Gross enrolment ratio (%) of Primary schools?
Offer a terse response. -24.52. In the year 2006, what is the difference between the Gross enrolment ratio (%) of Pre-primary schools and Gross enrolment ratio (%) of Secondary schools?
Your response must be concise. -5.48. In the year 2006, what is the difference between the Gross enrolment ratio (%) of Pre-primary schools and Gross enrolment ratio (%) of Tertiary schools?
Keep it short and to the point. 2.04. In the year 2006, what is the difference between the Gross enrolment ratio (%) in Primary schools and Gross enrolment ratio (%) in Secondary schools?
Offer a terse response. 19.03. In the year 2006, what is the difference between the Gross enrolment ratio (%) in Primary schools and Gross enrolment ratio (%) in Tertiary schools?
Make the answer very short. 26.56. In the year 2006, what is the difference between the Gross enrolment ratio (%) of Secondary schools and Gross enrolment ratio (%) of Tertiary schools?
Your response must be concise. 7.53. In the year 2007, what is the difference between the Gross enrolment ratio (%) of Pre-primary schools and Gross enrolment ratio (%) of Primary schools?
Make the answer very short. -24.08. In the year 2007, what is the difference between the Gross enrolment ratio (%) in Pre-primary schools and Gross enrolment ratio (%) in Secondary schools?
Your answer should be very brief. -4.6. In the year 2007, what is the difference between the Gross enrolment ratio (%) in Pre-primary schools and Gross enrolment ratio (%) in Tertiary schools?
Your response must be concise. 2.26. In the year 2007, what is the difference between the Gross enrolment ratio (%) of Primary schools and Gross enrolment ratio (%) of Secondary schools?
Ensure brevity in your answer.  19.49. In the year 2007, what is the difference between the Gross enrolment ratio (%) in Primary schools and Gross enrolment ratio (%) in Tertiary schools?
Provide a short and direct response. 26.34. In the year 2007, what is the difference between the Gross enrolment ratio (%) of Secondary schools and Gross enrolment ratio (%) of Tertiary schools?
Your answer should be compact. 6.85. In the year 2008, what is the difference between the Gross enrolment ratio (%) in Pre-primary schools and Gross enrolment ratio (%) in Primary schools?
Ensure brevity in your answer.  -22.72. In the year 2008, what is the difference between the Gross enrolment ratio (%) in Pre-primary schools and Gross enrolment ratio (%) in Secondary schools?
Offer a very short reply. -4.42. In the year 2008, what is the difference between the Gross enrolment ratio (%) in Pre-primary schools and Gross enrolment ratio (%) in Tertiary schools?
Your response must be concise. 2.73. In the year 2008, what is the difference between the Gross enrolment ratio (%) in Primary schools and Gross enrolment ratio (%) in Secondary schools?
Offer a very short reply. 18.3. In the year 2008, what is the difference between the Gross enrolment ratio (%) of Primary schools and Gross enrolment ratio (%) of Tertiary schools?
Make the answer very short. 25.45. In the year 2008, what is the difference between the Gross enrolment ratio (%) in Secondary schools and Gross enrolment ratio (%) in Tertiary schools?
Make the answer very short. 7.16. What is the ratio of the Gross enrolment ratio (%) of Pre-primary schools in 2002 to that in 2003?
Give a very brief answer. 0.77. What is the ratio of the Gross enrolment ratio (%) in Primary schools in 2002 to that in 2003?
Make the answer very short. 0.98. What is the ratio of the Gross enrolment ratio (%) of Secondary schools in 2002 to that in 2003?
Your answer should be very brief. 0.92. What is the ratio of the Gross enrolment ratio (%) in Tertiary schools in 2002 to that in 2003?
Ensure brevity in your answer.  1.22. What is the ratio of the Gross enrolment ratio (%) in Pre-primary schools in 2002 to that in 2004?
Your answer should be compact. 0.62. What is the ratio of the Gross enrolment ratio (%) in Secondary schools in 2002 to that in 2004?
Offer a terse response. 0.94. What is the ratio of the Gross enrolment ratio (%) of Tertiary schools in 2002 to that in 2004?
Provide a succinct answer. 0.96. What is the ratio of the Gross enrolment ratio (%) of Pre-primary schools in 2002 to that in 2005?
Your answer should be very brief. 0.49. What is the ratio of the Gross enrolment ratio (%) in Primary schools in 2002 to that in 2005?
Your answer should be compact. 1.03. What is the ratio of the Gross enrolment ratio (%) in Secondary schools in 2002 to that in 2005?
Offer a very short reply. 1.18. What is the ratio of the Gross enrolment ratio (%) in Tertiary schools in 2002 to that in 2005?
Your response must be concise. 0.8. What is the ratio of the Gross enrolment ratio (%) of Pre-primary schools in 2002 to that in 2006?
Give a very brief answer. 0.45. What is the ratio of the Gross enrolment ratio (%) of Primary schools in 2002 to that in 2006?
Your response must be concise. 1.06. What is the ratio of the Gross enrolment ratio (%) of Secondary schools in 2002 to that in 2006?
Your response must be concise. 1.02. What is the ratio of the Gross enrolment ratio (%) in Tertiary schools in 2002 to that in 2006?
Give a very brief answer. 0.78. What is the ratio of the Gross enrolment ratio (%) in Pre-primary schools in 2002 to that in 2007?
Make the answer very short. 0.44. What is the ratio of the Gross enrolment ratio (%) in Primary schools in 2002 to that in 2007?
Ensure brevity in your answer.  1.07. What is the ratio of the Gross enrolment ratio (%) of Secondary schools in 2002 to that in 2007?
Make the answer very short. 1.12. What is the ratio of the Gross enrolment ratio (%) in Tertiary schools in 2002 to that in 2007?
Give a very brief answer. 0.88. What is the ratio of the Gross enrolment ratio (%) in Pre-primary schools in 2002 to that in 2008?
Your answer should be very brief. 0.41. What is the ratio of the Gross enrolment ratio (%) of Primary schools in 2002 to that in 2008?
Provide a short and direct response. 1.11. What is the ratio of the Gross enrolment ratio (%) of Secondary schools in 2002 to that in 2008?
Your answer should be very brief. 1.11. What is the ratio of the Gross enrolment ratio (%) in Tertiary schools in 2002 to that in 2008?
Provide a short and direct response. 1.08. What is the ratio of the Gross enrolment ratio (%) of Pre-primary schools in 2003 to that in 2004?
Offer a very short reply. 0.81. What is the ratio of the Gross enrolment ratio (%) in Secondary schools in 2003 to that in 2004?
Provide a succinct answer. 1.02. What is the ratio of the Gross enrolment ratio (%) in Tertiary schools in 2003 to that in 2004?
Offer a terse response. 0.79. What is the ratio of the Gross enrolment ratio (%) of Pre-primary schools in 2003 to that in 2005?
Keep it short and to the point. 0.64. What is the ratio of the Gross enrolment ratio (%) in Primary schools in 2003 to that in 2005?
Your response must be concise. 1.05. What is the ratio of the Gross enrolment ratio (%) in Secondary schools in 2003 to that in 2005?
Make the answer very short. 1.28. What is the ratio of the Gross enrolment ratio (%) of Tertiary schools in 2003 to that in 2005?
Your response must be concise. 0.65. What is the ratio of the Gross enrolment ratio (%) of Pre-primary schools in 2003 to that in 2006?
Offer a very short reply. 0.59. What is the ratio of the Gross enrolment ratio (%) of Primary schools in 2003 to that in 2006?
Your answer should be very brief. 1.08. What is the ratio of the Gross enrolment ratio (%) in Secondary schools in 2003 to that in 2006?
Your response must be concise. 1.1. What is the ratio of the Gross enrolment ratio (%) in Tertiary schools in 2003 to that in 2006?
Provide a succinct answer. 0.64. What is the ratio of the Gross enrolment ratio (%) in Pre-primary schools in 2003 to that in 2007?
Your answer should be very brief. 0.58. What is the ratio of the Gross enrolment ratio (%) of Primary schools in 2003 to that in 2007?
Keep it short and to the point. 1.09. What is the ratio of the Gross enrolment ratio (%) in Secondary schools in 2003 to that in 2007?
Provide a succinct answer. 1.21. What is the ratio of the Gross enrolment ratio (%) in Tertiary schools in 2003 to that in 2007?
Provide a succinct answer. 0.72. What is the ratio of the Gross enrolment ratio (%) in Pre-primary schools in 2003 to that in 2008?
Your answer should be compact. 0.53. What is the ratio of the Gross enrolment ratio (%) of Primary schools in 2003 to that in 2008?
Make the answer very short. 1.13. What is the ratio of the Gross enrolment ratio (%) in Secondary schools in 2003 to that in 2008?
Your response must be concise. 1.2. What is the ratio of the Gross enrolment ratio (%) of Tertiary schools in 2003 to that in 2008?
Offer a very short reply. 0.89. What is the ratio of the Gross enrolment ratio (%) of Pre-primary schools in 2004 to that in 2005?
Ensure brevity in your answer.  0.79. What is the ratio of the Gross enrolment ratio (%) in Primary schools in 2004 to that in 2005?
Make the answer very short. 1.05. What is the ratio of the Gross enrolment ratio (%) in Secondary schools in 2004 to that in 2005?
Keep it short and to the point. 1.26. What is the ratio of the Gross enrolment ratio (%) in Tertiary schools in 2004 to that in 2005?
Ensure brevity in your answer.  0.83. What is the ratio of the Gross enrolment ratio (%) of Pre-primary schools in 2004 to that in 2006?
Ensure brevity in your answer.  0.73. What is the ratio of the Gross enrolment ratio (%) of Primary schools in 2004 to that in 2006?
Your answer should be compact. 1.07. What is the ratio of the Gross enrolment ratio (%) of Secondary schools in 2004 to that in 2006?
Offer a very short reply. 1.09. What is the ratio of the Gross enrolment ratio (%) in Tertiary schools in 2004 to that in 2006?
Your response must be concise. 0.82. What is the ratio of the Gross enrolment ratio (%) in Pre-primary schools in 2004 to that in 2007?
Your response must be concise. 0.71. What is the ratio of the Gross enrolment ratio (%) in Primary schools in 2004 to that in 2007?
Keep it short and to the point. 1.08. What is the ratio of the Gross enrolment ratio (%) in Secondary schools in 2004 to that in 2007?
Give a very brief answer. 1.2. What is the ratio of the Gross enrolment ratio (%) in Tertiary schools in 2004 to that in 2007?
Your response must be concise. 0.91. What is the ratio of the Gross enrolment ratio (%) of Pre-primary schools in 2004 to that in 2008?
Ensure brevity in your answer.  0.65. What is the ratio of the Gross enrolment ratio (%) of Primary schools in 2004 to that in 2008?
Your answer should be very brief. 1.13. What is the ratio of the Gross enrolment ratio (%) of Secondary schools in 2004 to that in 2008?
Give a very brief answer. 1.18. What is the ratio of the Gross enrolment ratio (%) of Tertiary schools in 2004 to that in 2008?
Give a very brief answer. 1.12. What is the ratio of the Gross enrolment ratio (%) in Pre-primary schools in 2005 to that in 2006?
Offer a very short reply. 0.92. What is the ratio of the Gross enrolment ratio (%) in Primary schools in 2005 to that in 2006?
Your answer should be very brief. 1.02. What is the ratio of the Gross enrolment ratio (%) in Secondary schools in 2005 to that in 2006?
Provide a succinct answer. 0.86. What is the ratio of the Gross enrolment ratio (%) of Tertiary schools in 2005 to that in 2006?
Ensure brevity in your answer.  0.99. What is the ratio of the Gross enrolment ratio (%) in Pre-primary schools in 2005 to that in 2007?
Offer a very short reply. 0.89. What is the ratio of the Gross enrolment ratio (%) in Primary schools in 2005 to that in 2007?
Provide a succinct answer. 1.04. What is the ratio of the Gross enrolment ratio (%) in Secondary schools in 2005 to that in 2007?
Your answer should be compact. 0.95. What is the ratio of the Gross enrolment ratio (%) in Tertiary schools in 2005 to that in 2007?
Give a very brief answer. 1.1. What is the ratio of the Gross enrolment ratio (%) of Pre-primary schools in 2005 to that in 2008?
Provide a short and direct response. 0.82. What is the ratio of the Gross enrolment ratio (%) in Primary schools in 2005 to that in 2008?
Offer a terse response. 1.08. What is the ratio of the Gross enrolment ratio (%) of Secondary schools in 2005 to that in 2008?
Offer a very short reply. 0.94. What is the ratio of the Gross enrolment ratio (%) of Tertiary schools in 2005 to that in 2008?
Give a very brief answer. 1.36. What is the ratio of the Gross enrolment ratio (%) of Primary schools in 2006 to that in 2007?
Ensure brevity in your answer.  1.01. What is the ratio of the Gross enrolment ratio (%) of Secondary schools in 2006 to that in 2007?
Offer a very short reply. 1.1. What is the ratio of the Gross enrolment ratio (%) in Tertiary schools in 2006 to that in 2007?
Keep it short and to the point. 1.12. What is the ratio of the Gross enrolment ratio (%) in Pre-primary schools in 2006 to that in 2008?
Provide a short and direct response. 0.9. What is the ratio of the Gross enrolment ratio (%) in Primary schools in 2006 to that in 2008?
Keep it short and to the point. 1.05. What is the ratio of the Gross enrolment ratio (%) in Secondary schools in 2006 to that in 2008?
Make the answer very short. 1.09. What is the ratio of the Gross enrolment ratio (%) of Tertiary schools in 2006 to that in 2008?
Provide a succinct answer. 1.38. What is the ratio of the Gross enrolment ratio (%) of Pre-primary schools in 2007 to that in 2008?
Your answer should be compact. 0.92. What is the ratio of the Gross enrolment ratio (%) in Primary schools in 2007 to that in 2008?
Make the answer very short. 1.04. What is the ratio of the Gross enrolment ratio (%) in Secondary schools in 2007 to that in 2008?
Your answer should be compact. 0.99. What is the ratio of the Gross enrolment ratio (%) of Tertiary schools in 2007 to that in 2008?
Provide a succinct answer. 1.23. What is the difference between the highest and the second highest Gross enrolment ratio (%) of Pre-primary schools?
Your answer should be compact. 0.28. What is the difference between the highest and the second highest Gross enrolment ratio (%) of Primary schools?
Give a very brief answer. 0.18. What is the difference between the highest and the second highest Gross enrolment ratio (%) of Secondary schools?
Offer a terse response. 0.15. What is the difference between the highest and the second highest Gross enrolment ratio (%) in Tertiary schools?
Give a very brief answer. 0.02. What is the difference between the highest and the lowest Gross enrolment ratio (%) of Pre-primary schools?
Make the answer very short. 2.12. What is the difference between the highest and the lowest Gross enrolment ratio (%) in Primary schools?
Provide a succinct answer. 3.55. What is the difference between the highest and the lowest Gross enrolment ratio (%) in Secondary schools?
Ensure brevity in your answer.  2.11. What is the difference between the highest and the lowest Gross enrolment ratio (%) of Tertiary schools?
Offer a terse response. 0.41. 